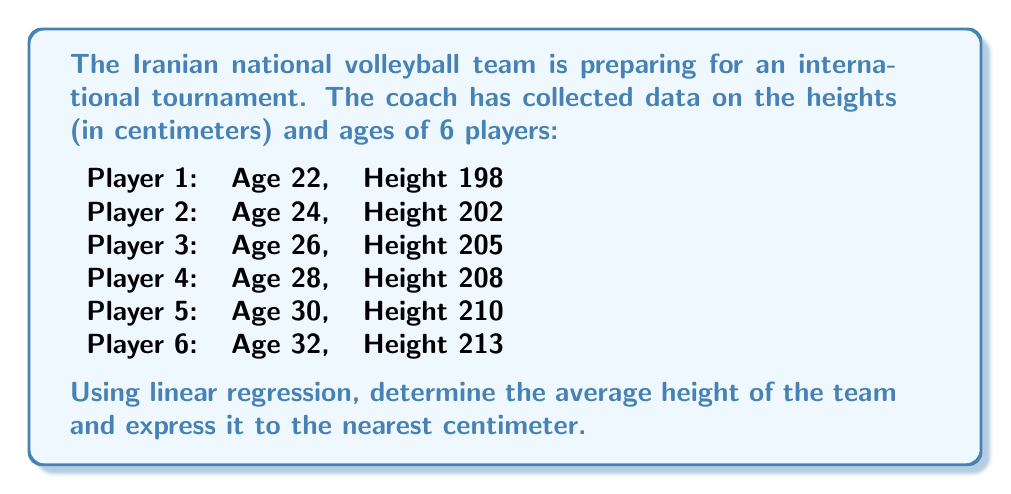Can you answer this question? To find the average height using linear regression, we'll follow these steps:

1. Calculate the means of age ($\bar{x}$) and height ($\bar{y}$):
   $\bar{x} = \frac{22 + 24 + 26 + 28 + 30 + 32}{6} = 27$
   $\bar{y} = \frac{198 + 202 + 205 + 208 + 210 + 213}{6} = 206$

2. Calculate the slope (m) of the regression line:
   $m = \frac{\sum(x_i - \bar{x})(y_i - \bar{y})}{\sum(x_i - \bar{x})^2}$

   Create a table to calculate the numerator and denominator:
   
   | $x_i$ | $y_i$ | $x_i - \bar{x}$ | $y_i - \bar{y}$ | $(x_i - \bar{x})(y_i - \bar{y})$ | $(x_i - \bar{x})^2$ |
   |-------|-------|-----------------|------------------|----------------------------------|---------------------|
   | 22    | 198   | -5              | -8               | 40                               | 25                  |
   | 24    | 202   | -3              | -4               | 12                               | 9                   |
   | 26    | 205   | -1              | -1               | 1                                | 1                   |
   | 28    | 208   | 1               | 2                | 2                                | 1                   |
   | 30    | 210   | 3               | 4                | 12                               | 9                   |
   | 32    | 213   | 5               | 7                | 35                               | 25                  |
   
   $m = \frac{40 + 12 + 1 + 2 + 12 + 35}{25 + 9 + 1 + 1 + 9 + 25} = \frac{102}{70} = 1.457$

3. Calculate the y-intercept (b) using the point-slope form:
   $b = \bar{y} - m\bar{x} = 206 - 1.457 * 27 = 166.661$

4. The regression line equation is:
   $y = 1.457x + 166.661$

5. To find the average height, substitute the average age (27) into the equation:
   $y = 1.457 * 27 + 166.661 = 206.0$

6. Round to the nearest centimeter:
   Average height ≈ 206 cm
Answer: 206 cm 